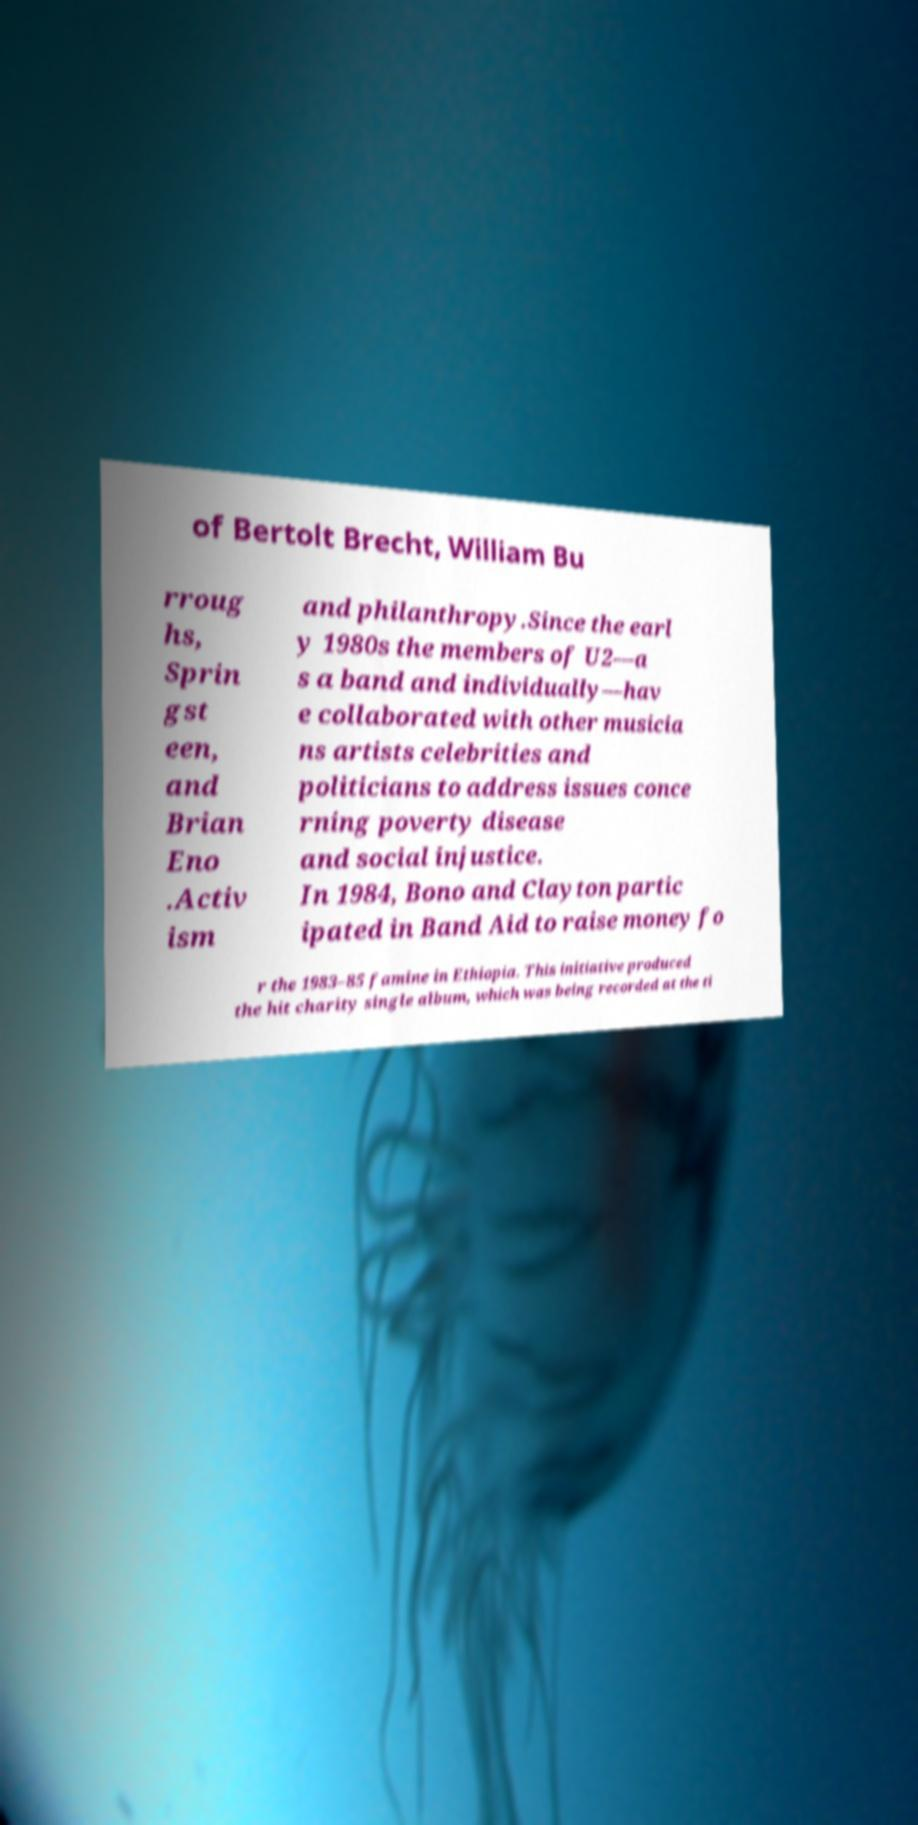Please identify and transcribe the text found in this image. of Bertolt Brecht, William Bu rroug hs, Sprin gst een, and Brian Eno .Activ ism and philanthropy.Since the earl y 1980s the members of U2—a s a band and individually—hav e collaborated with other musicia ns artists celebrities and politicians to address issues conce rning poverty disease and social injustice. In 1984, Bono and Clayton partic ipated in Band Aid to raise money fo r the 1983–85 famine in Ethiopia. This initiative produced the hit charity single album, which was being recorded at the ti 